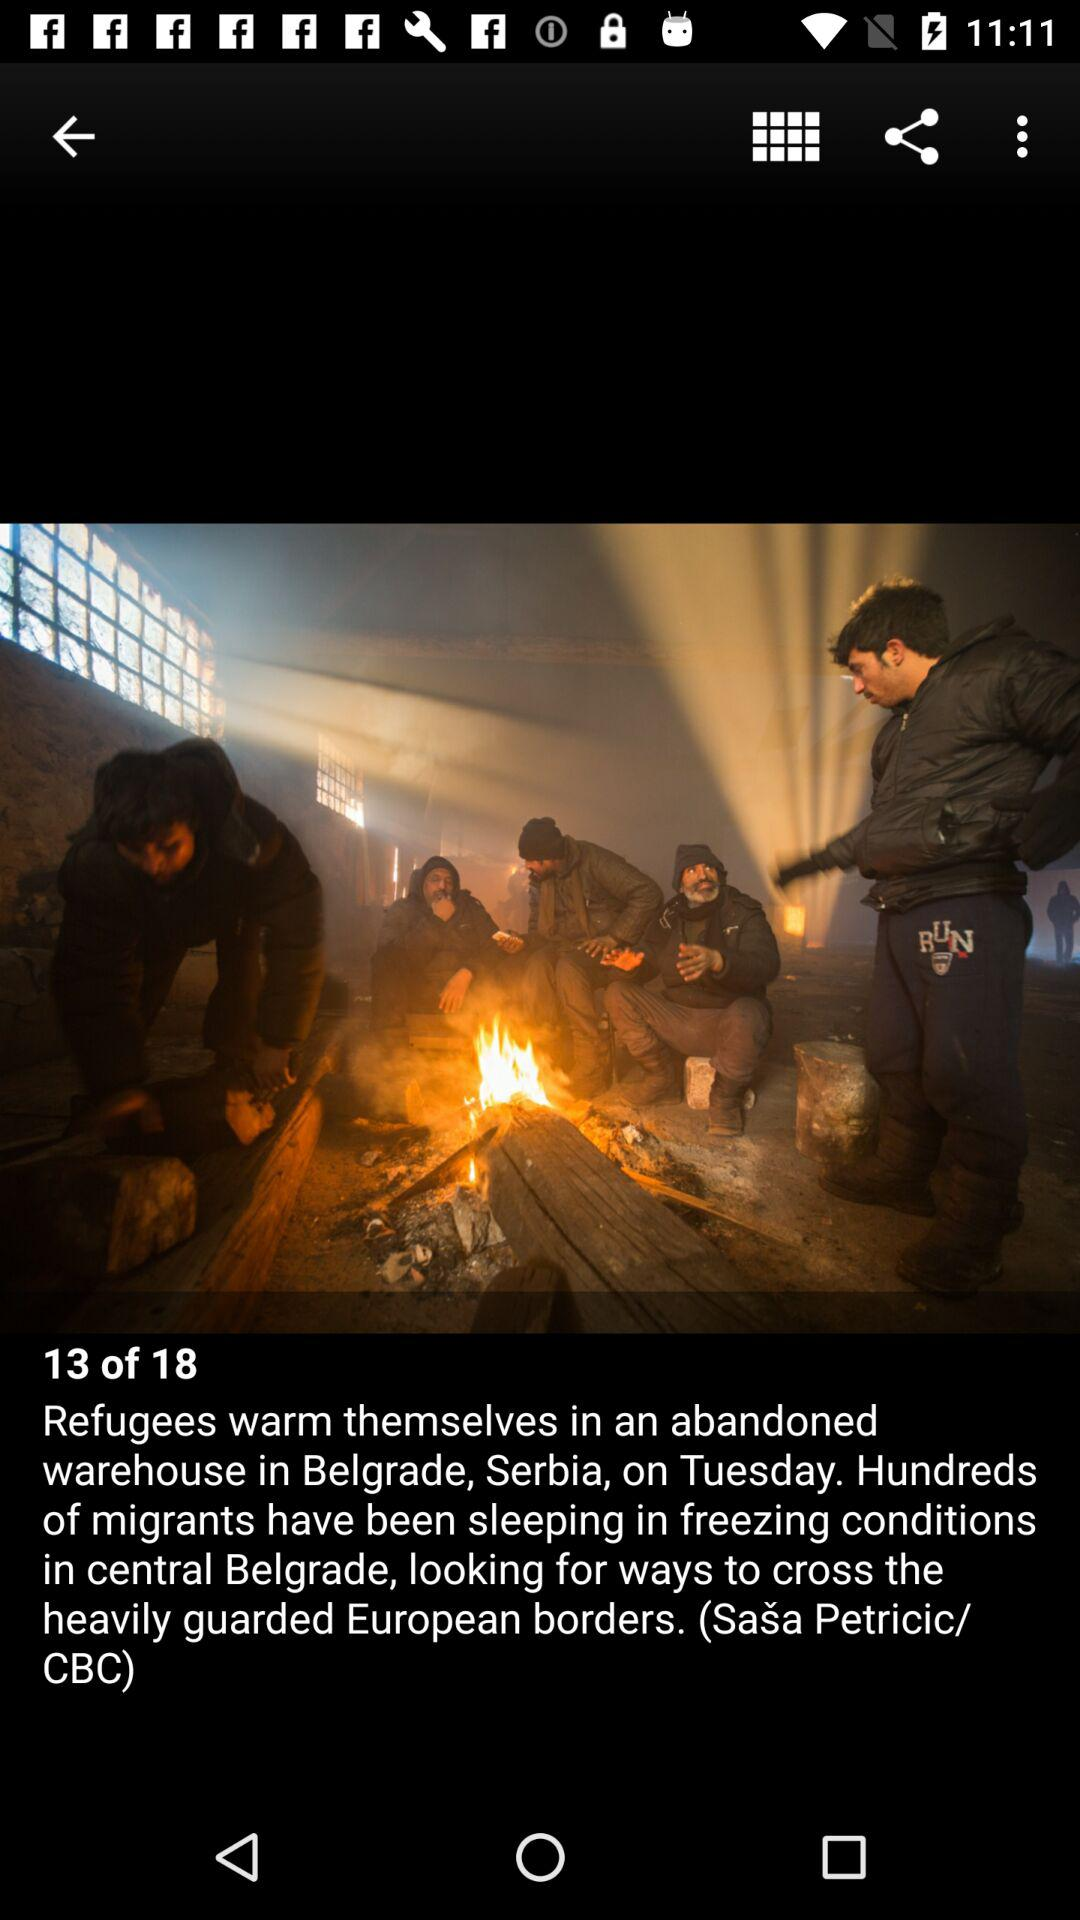What is the day? The day is Tuesday. 